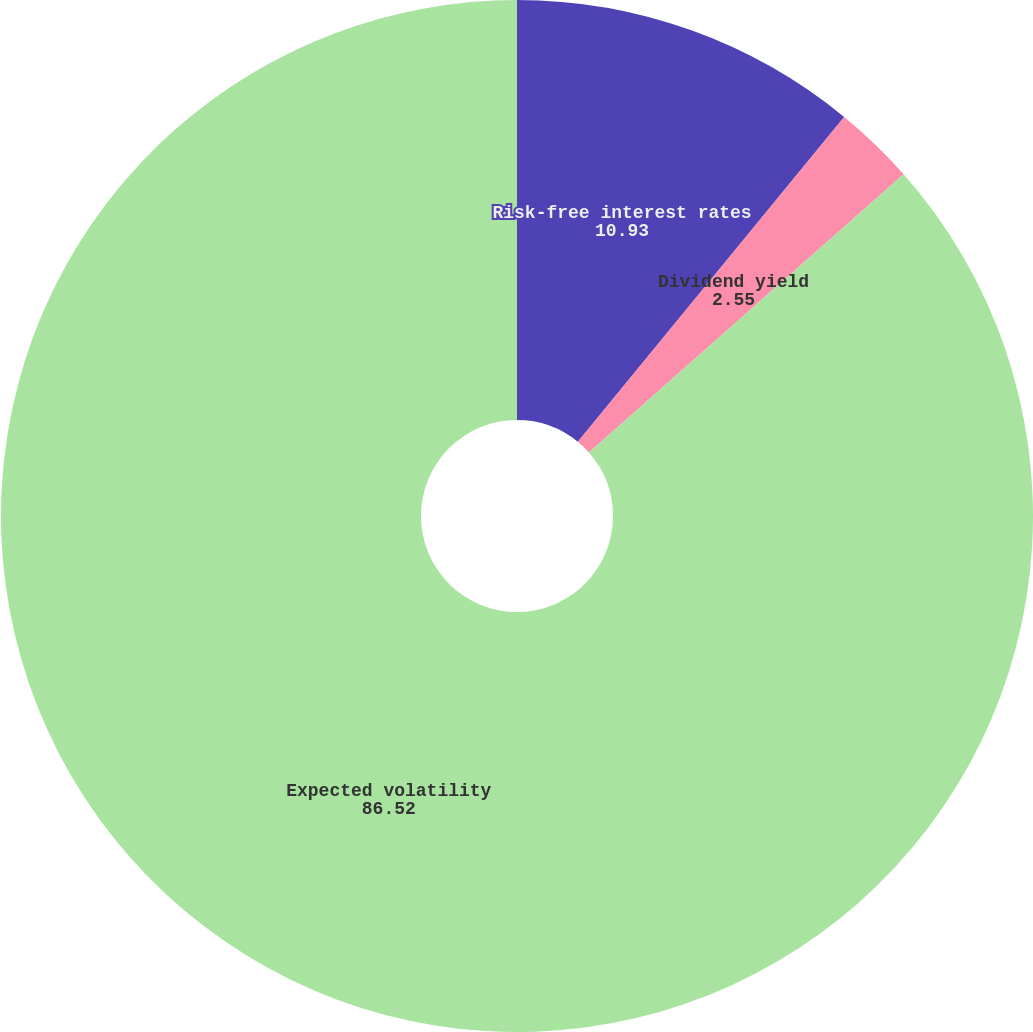Convert chart. <chart><loc_0><loc_0><loc_500><loc_500><pie_chart><fcel>Risk-free interest rates<fcel>Dividend yield<fcel>Expected volatility<nl><fcel>10.93%<fcel>2.55%<fcel>86.52%<nl></chart> 